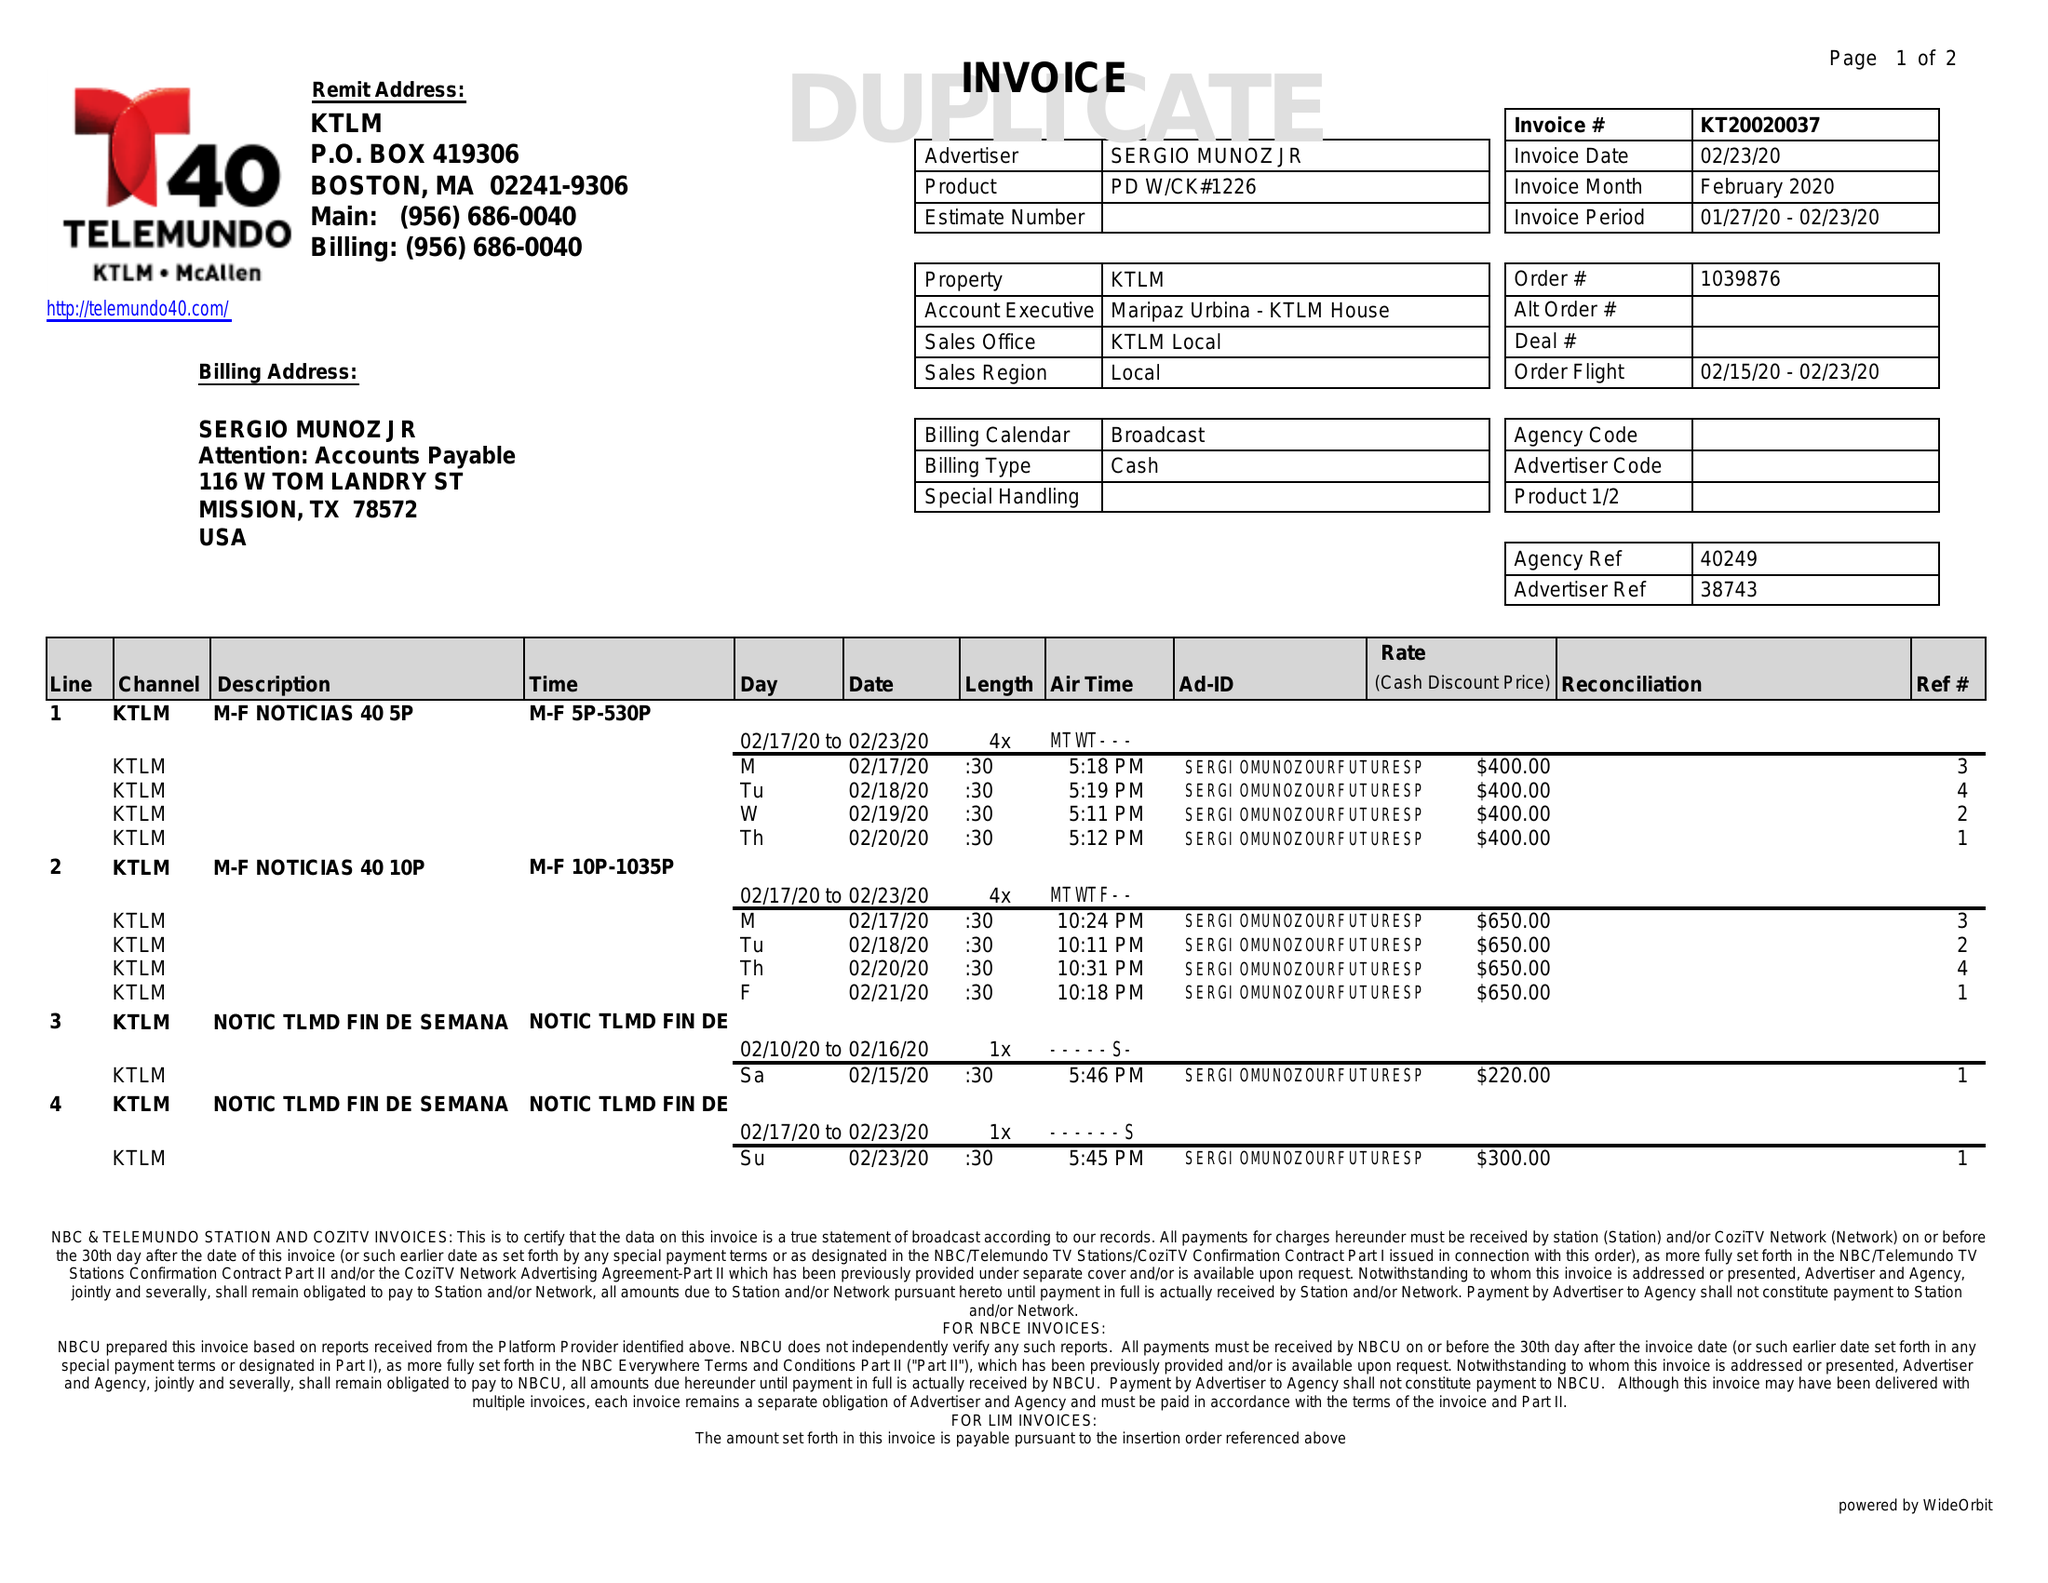What is the value for the flight_to?
Answer the question using a single word or phrase. 02/23/20 